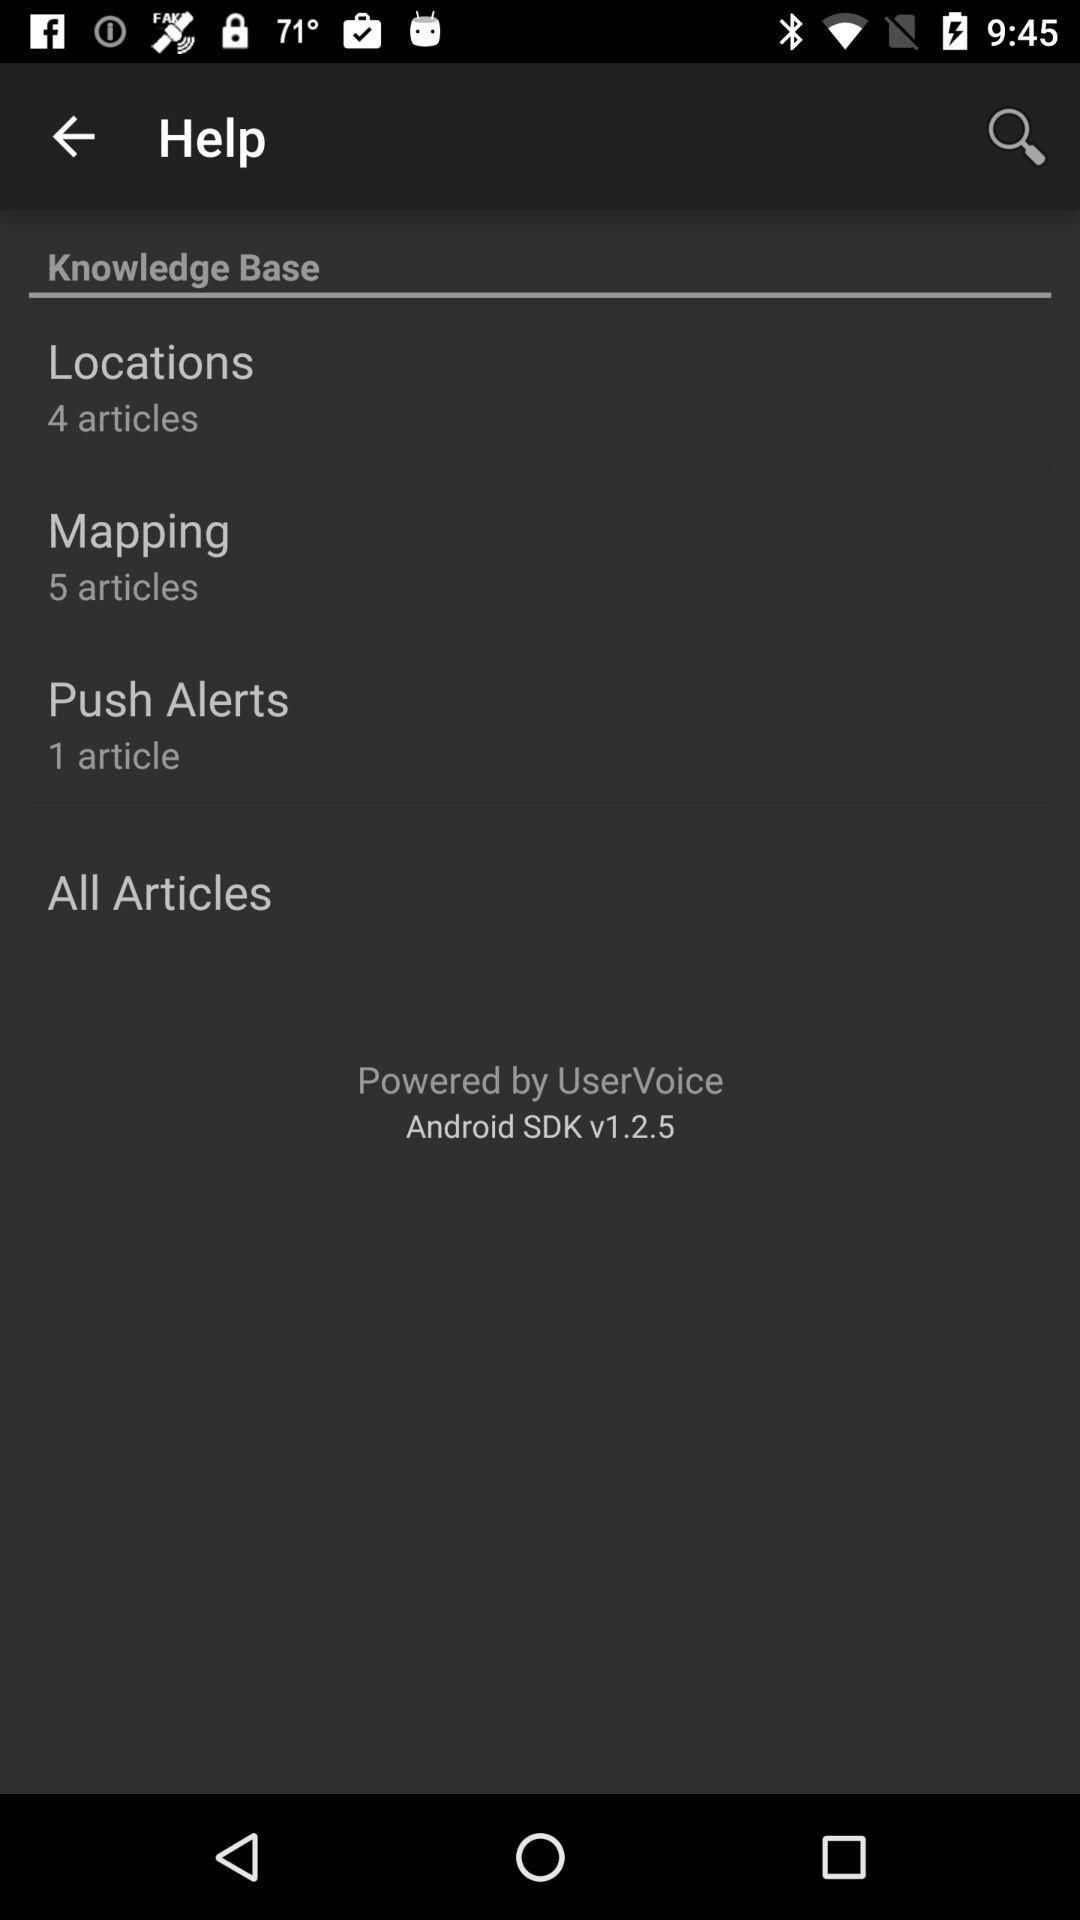How many articles are in the "Locations"? There are 4 articles in the "Locations". 